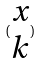<formula> <loc_0><loc_0><loc_500><loc_500>( \begin{matrix} x \\ k \end{matrix} )</formula> 